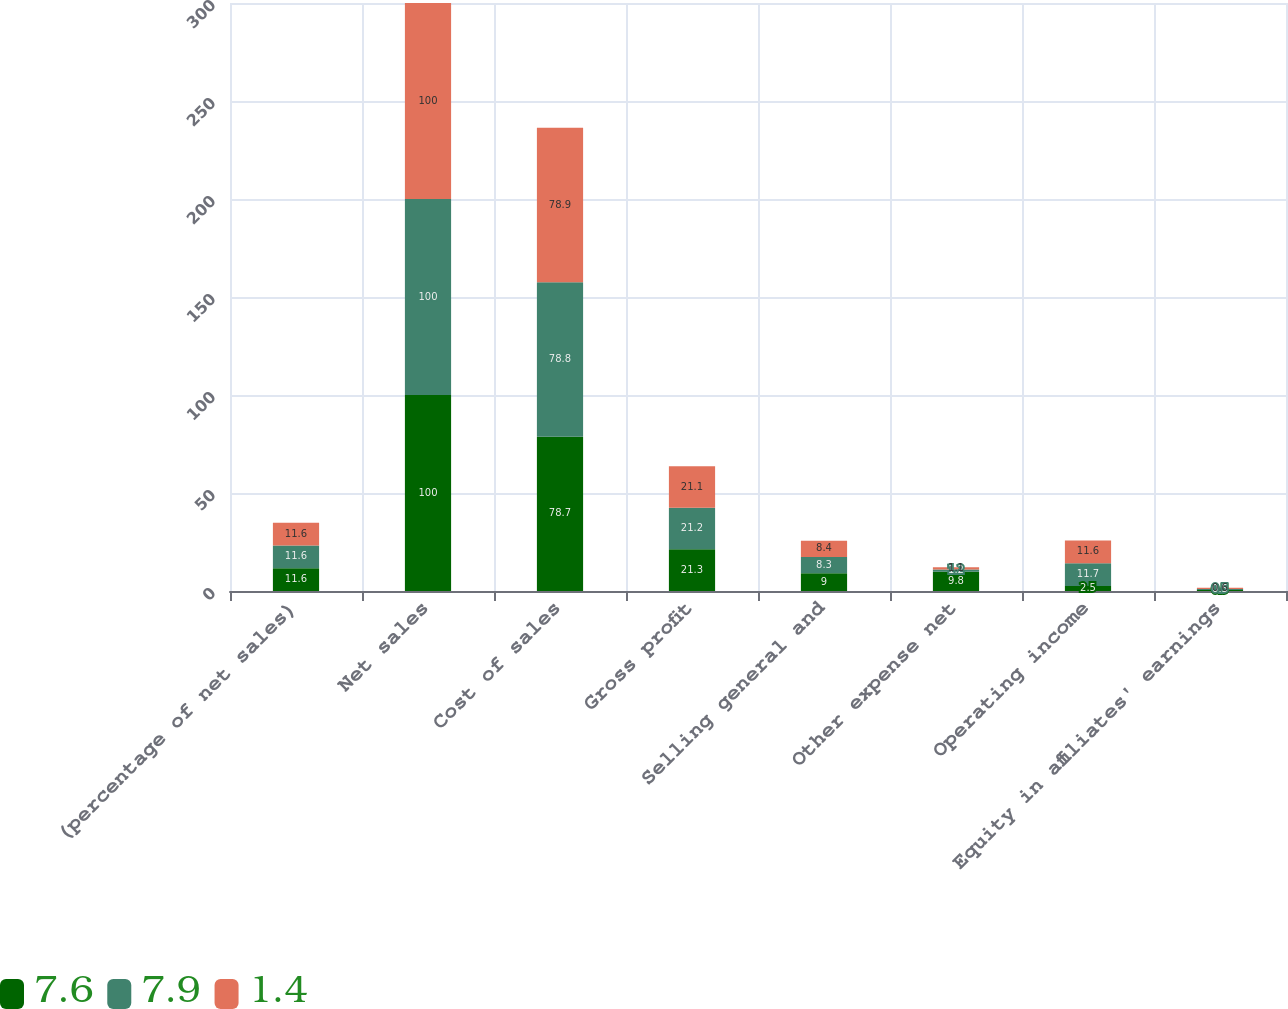<chart> <loc_0><loc_0><loc_500><loc_500><stacked_bar_chart><ecel><fcel>(percentage of net sales)<fcel>Net sales<fcel>Cost of sales<fcel>Gross profit<fcel>Selling general and<fcel>Other expense net<fcel>Operating income<fcel>Equity in affiliates' earnings<nl><fcel>7.6<fcel>11.6<fcel>100<fcel>78.7<fcel>21.3<fcel>9<fcel>9.8<fcel>2.5<fcel>0.5<nl><fcel>7.9<fcel>11.6<fcel>100<fcel>78.8<fcel>21.2<fcel>8.3<fcel>1.2<fcel>11.7<fcel>0.5<nl><fcel>1.4<fcel>11.6<fcel>100<fcel>78.9<fcel>21.1<fcel>8.4<fcel>1.1<fcel>11.6<fcel>0.6<nl></chart> 